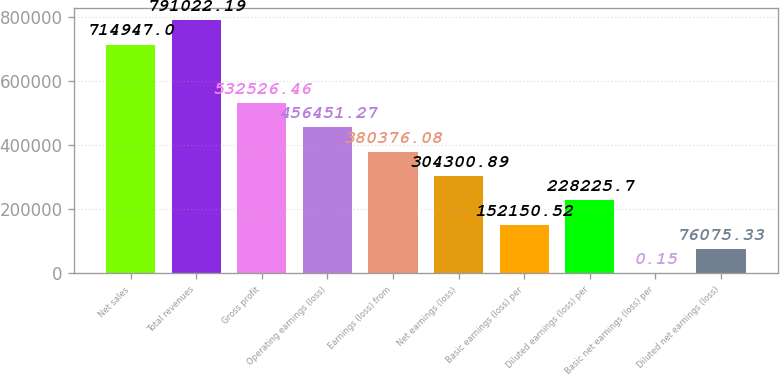<chart> <loc_0><loc_0><loc_500><loc_500><bar_chart><fcel>Net sales<fcel>Total revenues<fcel>Gross profit<fcel>Operating earnings (loss)<fcel>Earnings (loss) from<fcel>Net earnings (loss)<fcel>Basic earnings (loss) per<fcel>Diluted earnings (loss) per<fcel>Basic net earnings (loss) per<fcel>Diluted net earnings (loss)<nl><fcel>714947<fcel>791022<fcel>532526<fcel>456451<fcel>380376<fcel>304301<fcel>152151<fcel>228226<fcel>0.15<fcel>76075.3<nl></chart> 